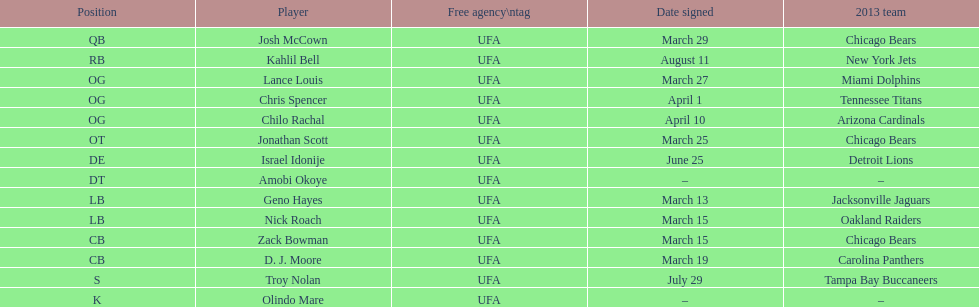What is the total of 2013 teams on the chart? 10. 